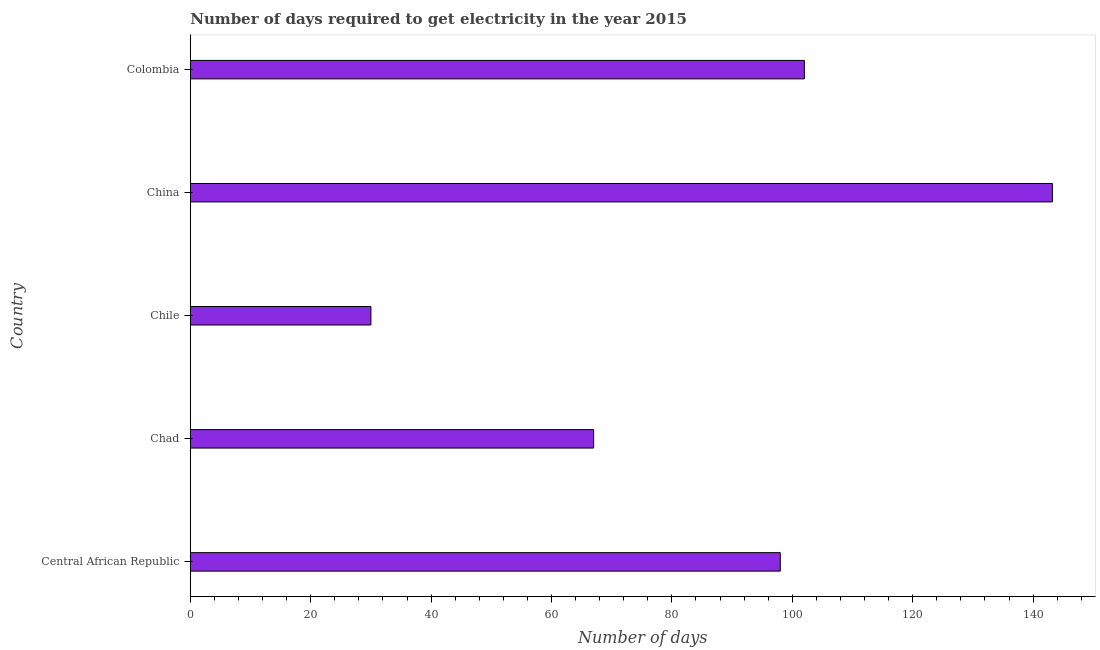Does the graph contain grids?
Your answer should be compact. No. What is the title of the graph?
Keep it short and to the point. Number of days required to get electricity in the year 2015. What is the label or title of the X-axis?
Offer a terse response. Number of days. What is the label or title of the Y-axis?
Your answer should be compact. Country. Across all countries, what is the maximum time to get electricity?
Make the answer very short. 143.2. In which country was the time to get electricity maximum?
Ensure brevity in your answer.  China. What is the sum of the time to get electricity?
Provide a succinct answer. 440.2. What is the average time to get electricity per country?
Your response must be concise. 88.04. In how many countries, is the time to get electricity greater than 12 ?
Keep it short and to the point. 5. What is the ratio of the time to get electricity in Central African Republic to that in China?
Ensure brevity in your answer.  0.68. Is the time to get electricity in Central African Republic less than that in Chad?
Your response must be concise. No. What is the difference between the highest and the second highest time to get electricity?
Offer a terse response. 41.2. What is the difference between the highest and the lowest time to get electricity?
Ensure brevity in your answer.  113.2. How many bars are there?
Provide a succinct answer. 5. Are all the bars in the graph horizontal?
Ensure brevity in your answer.  Yes. What is the Number of days in Central African Republic?
Ensure brevity in your answer.  98. What is the Number of days in Chile?
Keep it short and to the point. 30. What is the Number of days in China?
Provide a succinct answer. 143.2. What is the Number of days of Colombia?
Provide a succinct answer. 102. What is the difference between the Number of days in Central African Republic and Chile?
Offer a very short reply. 68. What is the difference between the Number of days in Central African Republic and China?
Your answer should be compact. -45.2. What is the difference between the Number of days in Chad and China?
Provide a succinct answer. -76.2. What is the difference between the Number of days in Chad and Colombia?
Offer a terse response. -35. What is the difference between the Number of days in Chile and China?
Offer a terse response. -113.2. What is the difference between the Number of days in Chile and Colombia?
Make the answer very short. -72. What is the difference between the Number of days in China and Colombia?
Offer a terse response. 41.2. What is the ratio of the Number of days in Central African Republic to that in Chad?
Your answer should be compact. 1.46. What is the ratio of the Number of days in Central African Republic to that in Chile?
Offer a terse response. 3.27. What is the ratio of the Number of days in Central African Republic to that in China?
Give a very brief answer. 0.68. What is the ratio of the Number of days in Central African Republic to that in Colombia?
Give a very brief answer. 0.96. What is the ratio of the Number of days in Chad to that in Chile?
Offer a very short reply. 2.23. What is the ratio of the Number of days in Chad to that in China?
Keep it short and to the point. 0.47. What is the ratio of the Number of days in Chad to that in Colombia?
Provide a short and direct response. 0.66. What is the ratio of the Number of days in Chile to that in China?
Provide a short and direct response. 0.21. What is the ratio of the Number of days in Chile to that in Colombia?
Your answer should be very brief. 0.29. What is the ratio of the Number of days in China to that in Colombia?
Your answer should be very brief. 1.4. 